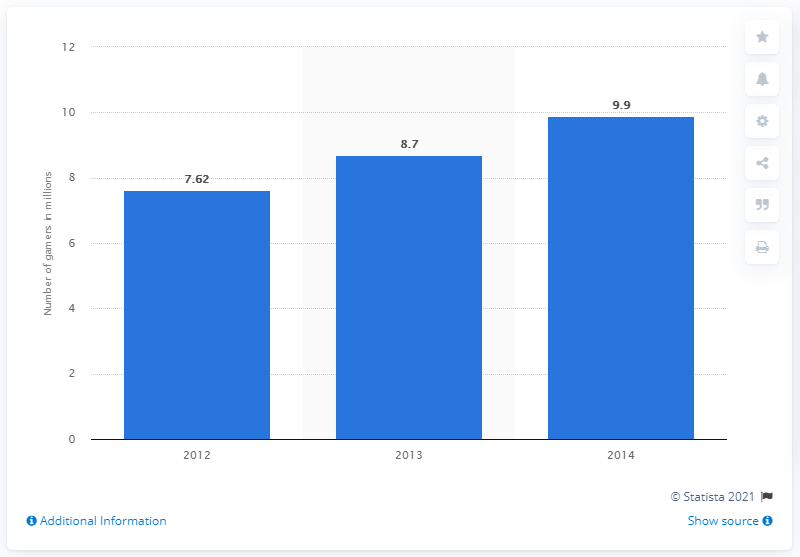Specify some key components in this picture. In 2012, there were 7,620 online gamers in Malaysia. The predicted number of online gamers in Malaysia in 2014 was 9.9 million. 